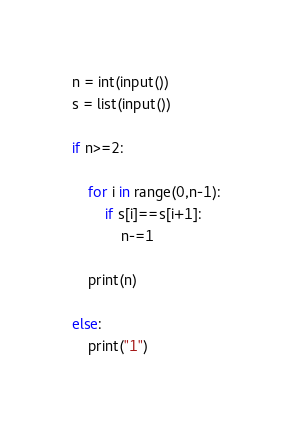<code> <loc_0><loc_0><loc_500><loc_500><_Python_>n = int(input())
s = list(input())

if n>=2:

    for i in range(0,n-1):
        if s[i]==s[i+1]:
            n-=1

    print(n)

else:
    print("1")
</code> 